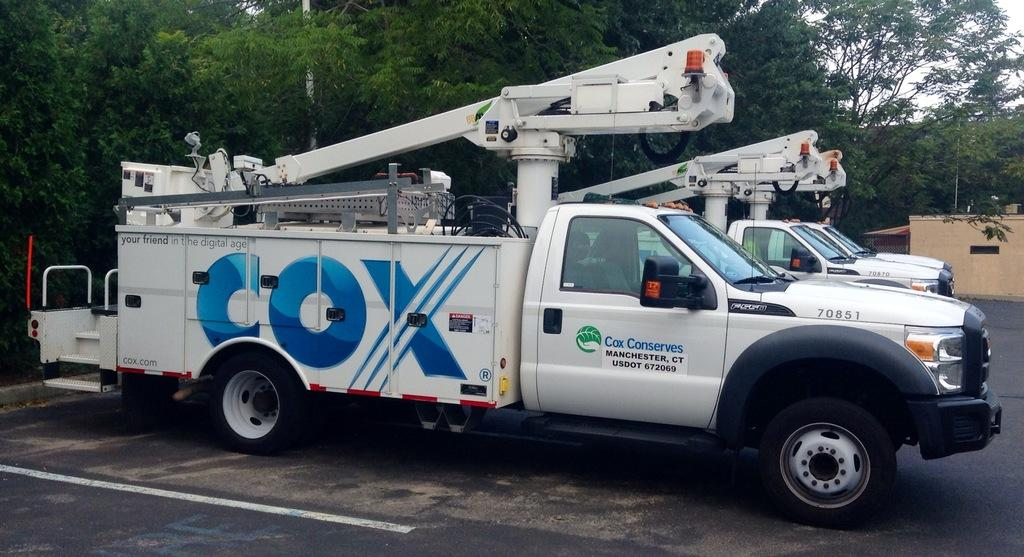What type of vehicles are parked in the parking space in the image? There are cable trucks parked in a parking space in the image. What structure can be seen on the right side of the image? There is a house on the right side of the image. What can be seen in the background of the image? There are trees visible in the background of the image. What type of wax is being used to maintain the position of the trees in the image? There is no wax or any indication of wax being used to maintain the position of the trees in the image. 